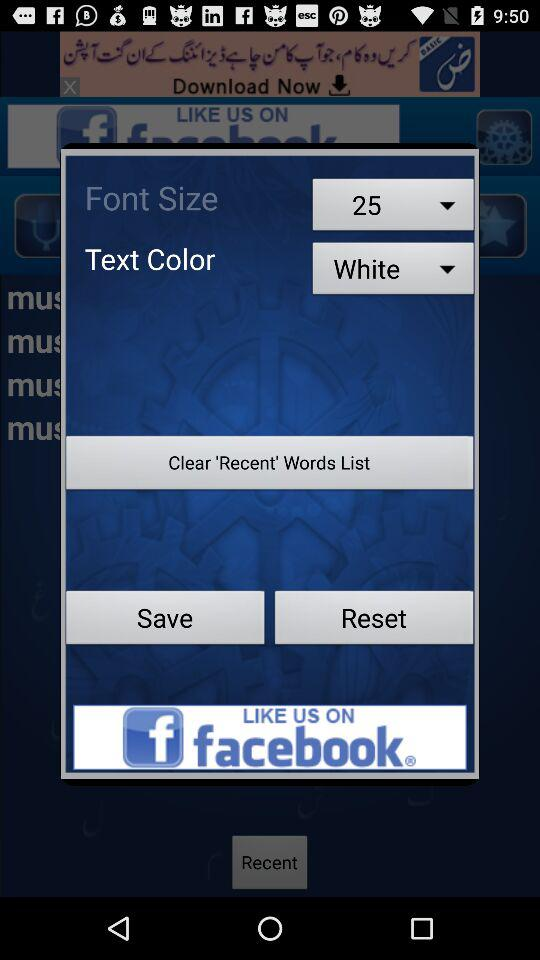What is the font size? The font size is 25. 